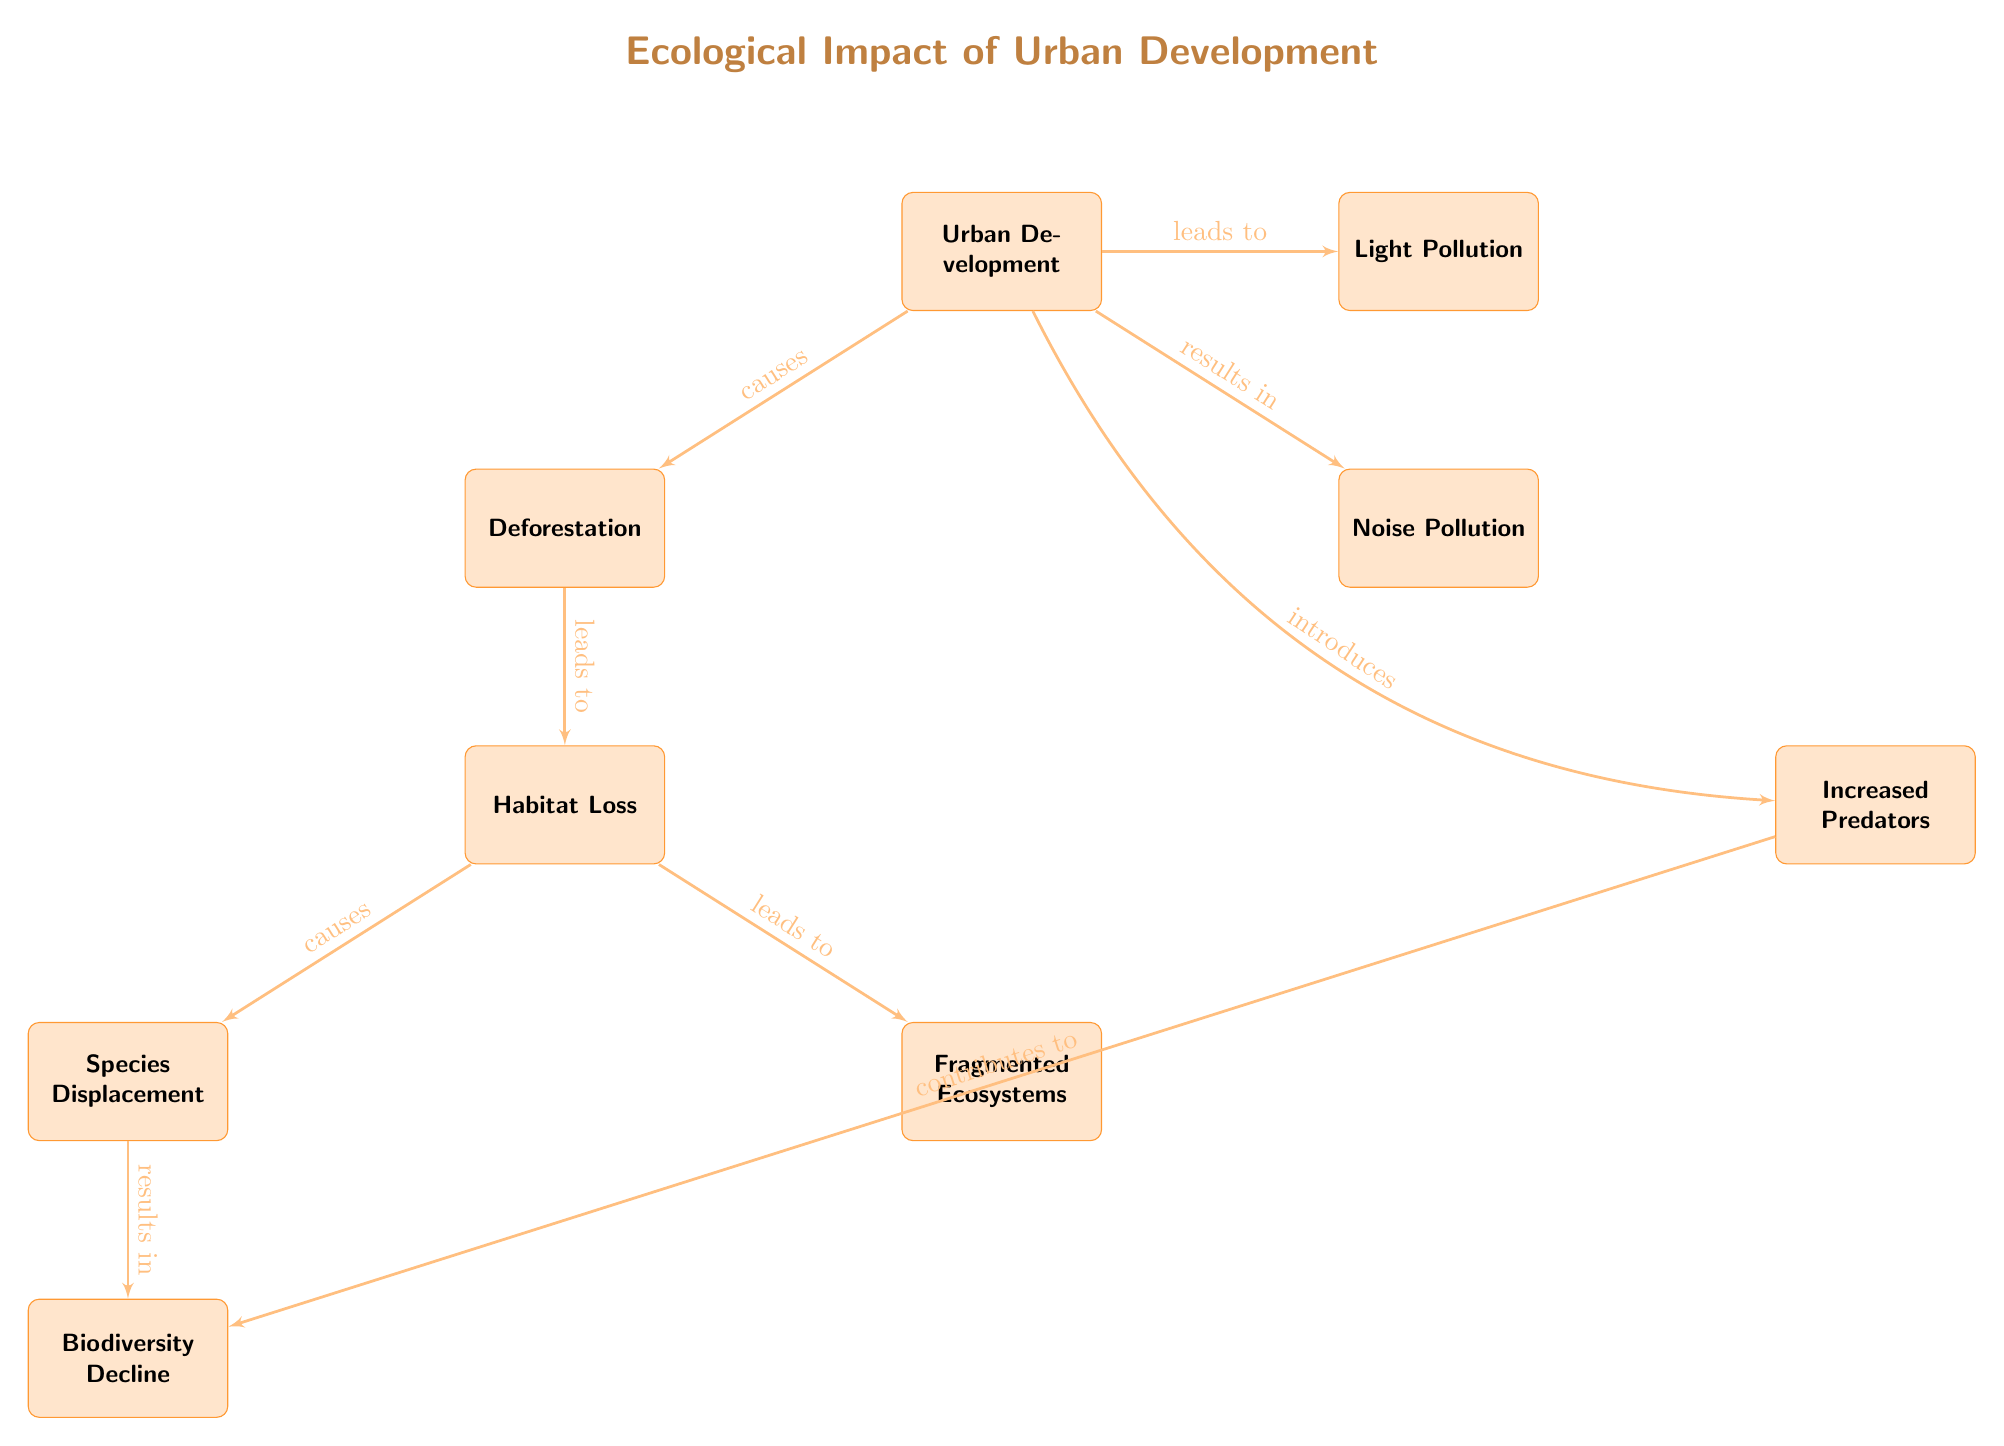What is the main cause highlighted in the diagram? The diagram shows "Urban Development" as the main cause at the top of the flowchart. It connects to various negative impacts on wildlife and ecosystems.
Answer: Urban Development How many nodes are present in the diagram? Counting all individual elements represented in the diagram, including "Urban Development," the impacts, and the subsequent consequences, gives a total of 10 nodes.
Answer: 10 What effect does "Deforestation" have according to the diagram? Following the arrows from "Deforestation," it leads to "Habitat Loss," indicating this is the direct effect shown in the diagram.
Answer: Habitat Loss Which node represents decreased wildlife diversity? The last node in the sequence affected by various impacts is "Biodiversity Decline," indicating this is where decreased wildlife diversity is represented.
Answer: Biodiversity Decline What factors lead to "Increased Predators"? The diagram indicates that "Urban Development" introduces various elements that result in "Increased Predators." This implies that urbanization leads to new predator dynamics affecting wildlife.
Answer: Urban Development What relationship exists between "Species Displacement" and "Biodiversity Decline"? "Species Displacement" leads to "Biodiversity Decline" according to the flow of the diagram, demonstrating a direct sequential relationship between them.
Answer: leads to How does "Noise Pollution" contribute to wildlife issues? The diagram shows "Noise Pollution" directly affects wildlife populations as it connects to "Increased Predators," suggesting that noise from urban development introduces predatory challenges.
Answer: Increased Predators What is the end result of the processes shown in the diagram? The last consequence connected to the various impacts is "Biodiversity Decline," which is effectively the overall result of the preceding nodes.
Answer: Biodiversity Decline How many edges are depicted in the diagram? Counting the connections between the nodes, there are 8 distinct edges represented in the flowchart, defining how each aspect influences the others.
Answer: 8 